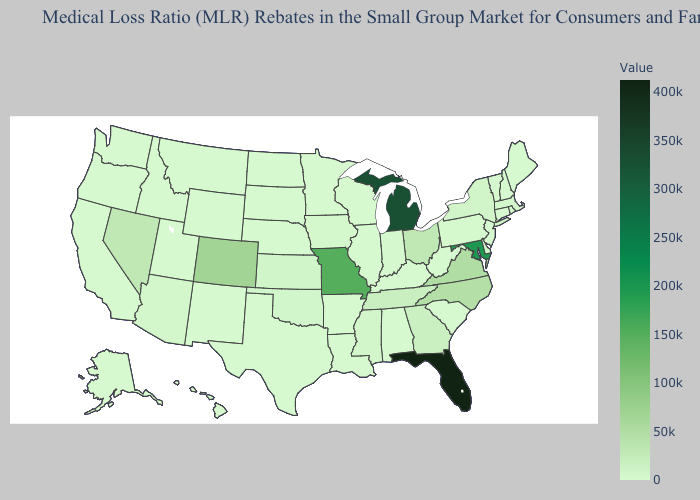Does New Jersey have the lowest value in the USA?
Keep it brief. Yes. Among the states that border South Dakota , does Iowa have the highest value?
Quick response, please. Yes. Among the states that border Florida , which have the highest value?
Quick response, please. Georgia. Does Kansas have the lowest value in the USA?
Give a very brief answer. No. Does South Dakota have the highest value in the MidWest?
Keep it brief. No. Among the states that border New Jersey , does Delaware have the highest value?
Be succinct. No. 